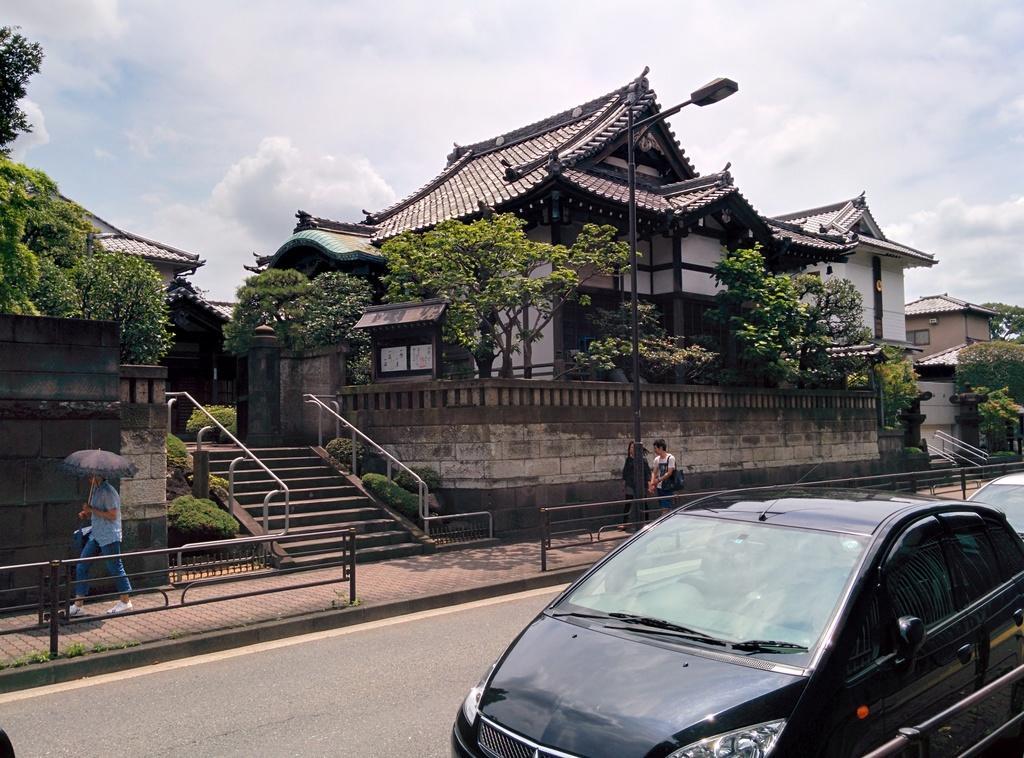Could you give a brief overview of what you see in this image? At the bottom, we see the cars moving on the road. In the middle, we see three people are walking on the footpath. Beside them, we see a light pole and the railing. The man on the left side is wearing a blue shirt and he is holding an umbrella in his hands. In the middle, we see the staircase and the stair railing. There are trees and the buildings in the background. At the top, we see the sky and the clouds. 